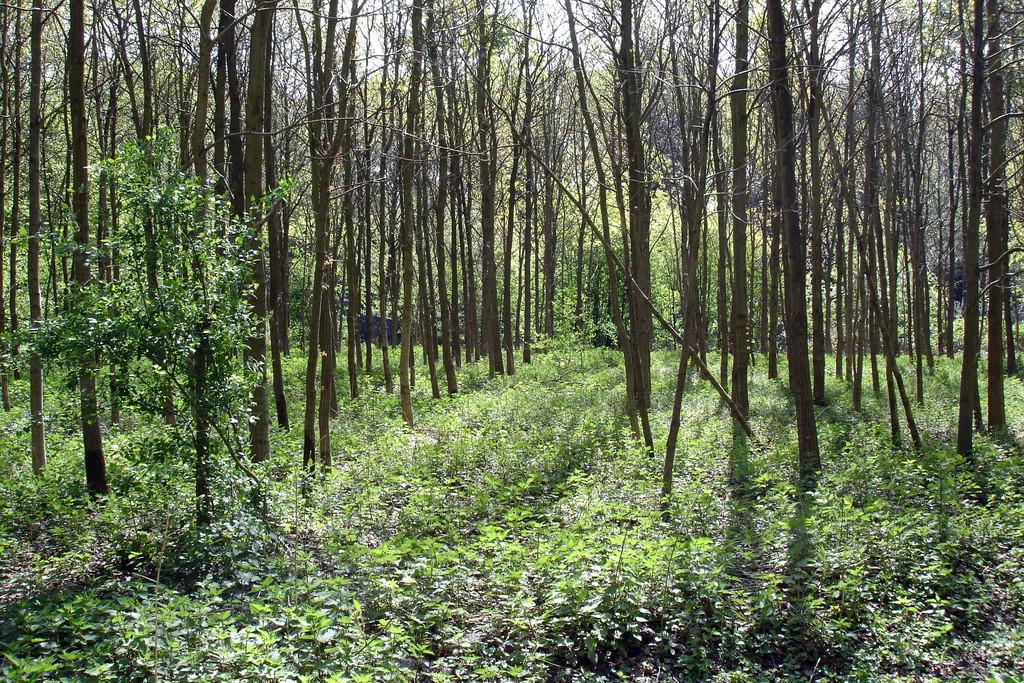In one or two sentences, can you explain what this image depicts? In this picture I can see many trees, plants and grass. At the top there is a sky. At the bottom I can see the leaves. 